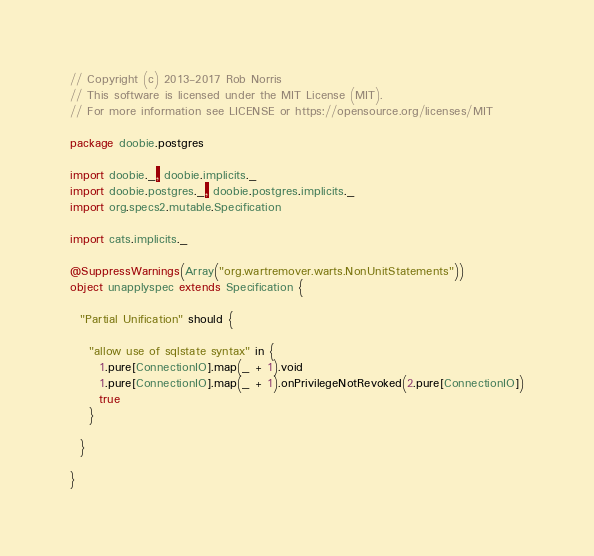Convert code to text. <code><loc_0><loc_0><loc_500><loc_500><_Scala_>// Copyright (c) 2013-2017 Rob Norris
// This software is licensed under the MIT License (MIT).
// For more information see LICENSE or https://opensource.org/licenses/MIT

package doobie.postgres

import doobie._, doobie.implicits._
import doobie.postgres._, doobie.postgres.implicits._
import org.specs2.mutable.Specification

import cats.implicits._

@SuppressWarnings(Array("org.wartremover.warts.NonUnitStatements"))
object unapplyspec extends Specification {

  "Partial Unification" should {

    "allow use of sqlstate syntax" in {
      1.pure[ConnectionIO].map(_ + 1).void
      1.pure[ConnectionIO].map(_ + 1).onPrivilegeNotRevoked(2.pure[ConnectionIO])
      true
    }

  }

}
</code> 